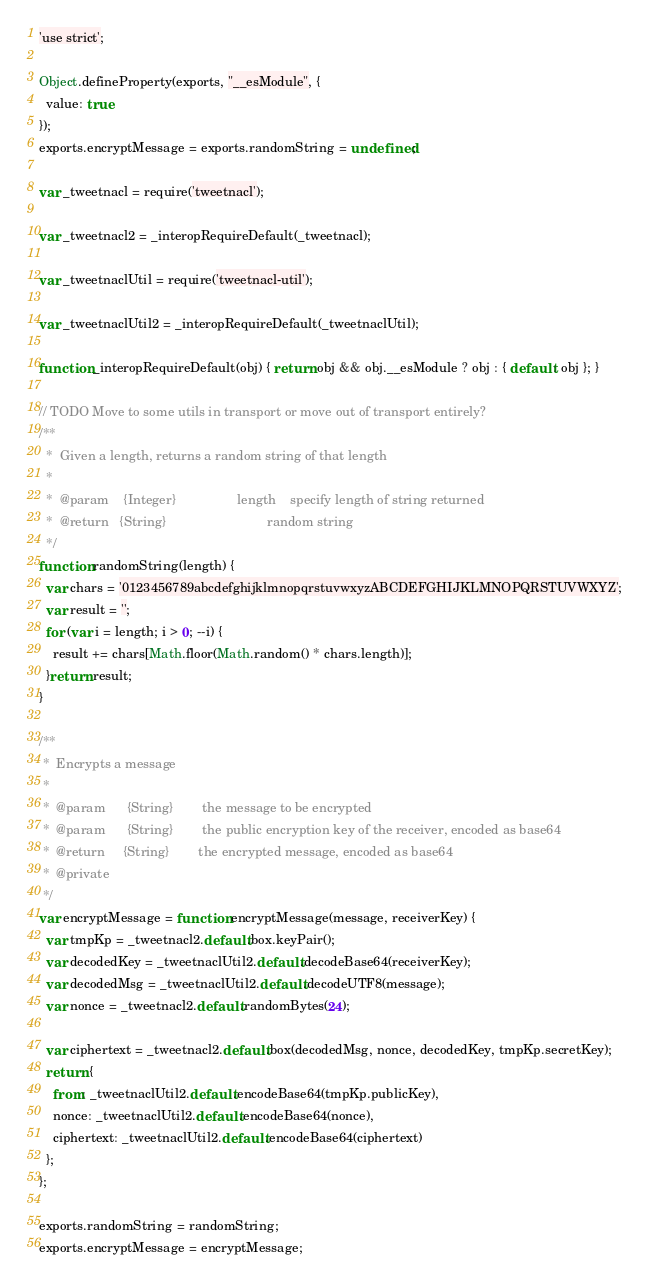<code> <loc_0><loc_0><loc_500><loc_500><_JavaScript_>'use strict';

Object.defineProperty(exports, "__esModule", {
  value: true
});
exports.encryptMessage = exports.randomString = undefined;

var _tweetnacl = require('tweetnacl');

var _tweetnacl2 = _interopRequireDefault(_tweetnacl);

var _tweetnaclUtil = require('tweetnacl-util');

var _tweetnaclUtil2 = _interopRequireDefault(_tweetnaclUtil);

function _interopRequireDefault(obj) { return obj && obj.__esModule ? obj : { default: obj }; }

// TODO Move to some utils in transport or move out of transport entirely?
/**
  *  Given a length, returns a random string of that length
  *
  *  @param    {Integer}                 length    specify length of string returned
  *  @return   {String}                            random string
  */
function randomString(length) {
  var chars = '0123456789abcdefghijklmnopqrstuvwxyzABCDEFGHIJKLMNOPQRSTUVWXYZ';
  var result = '';
  for (var i = length; i > 0; --i) {
    result += chars[Math.floor(Math.random() * chars.length)];
  }return result;
}

/**
 *  Encrypts a message
 *
 *  @param      {String}        the message to be encrypted
 *  @param      {String}        the public encryption key of the receiver, encoded as base64
 *  @return     {String}        the encrypted message, encoded as base64
 *  @private
 */
var encryptMessage = function encryptMessage(message, receiverKey) {
  var tmpKp = _tweetnacl2.default.box.keyPair();
  var decodedKey = _tweetnaclUtil2.default.decodeBase64(receiverKey);
  var decodedMsg = _tweetnaclUtil2.default.decodeUTF8(message);
  var nonce = _tweetnacl2.default.randomBytes(24);

  var ciphertext = _tweetnacl2.default.box(decodedMsg, nonce, decodedKey, tmpKp.secretKey);
  return {
    from: _tweetnaclUtil2.default.encodeBase64(tmpKp.publicKey),
    nonce: _tweetnaclUtil2.default.encodeBase64(nonce),
    ciphertext: _tweetnaclUtil2.default.encodeBase64(ciphertext)
  };
};

exports.randomString = randomString;
exports.encryptMessage = encryptMessage;</code> 